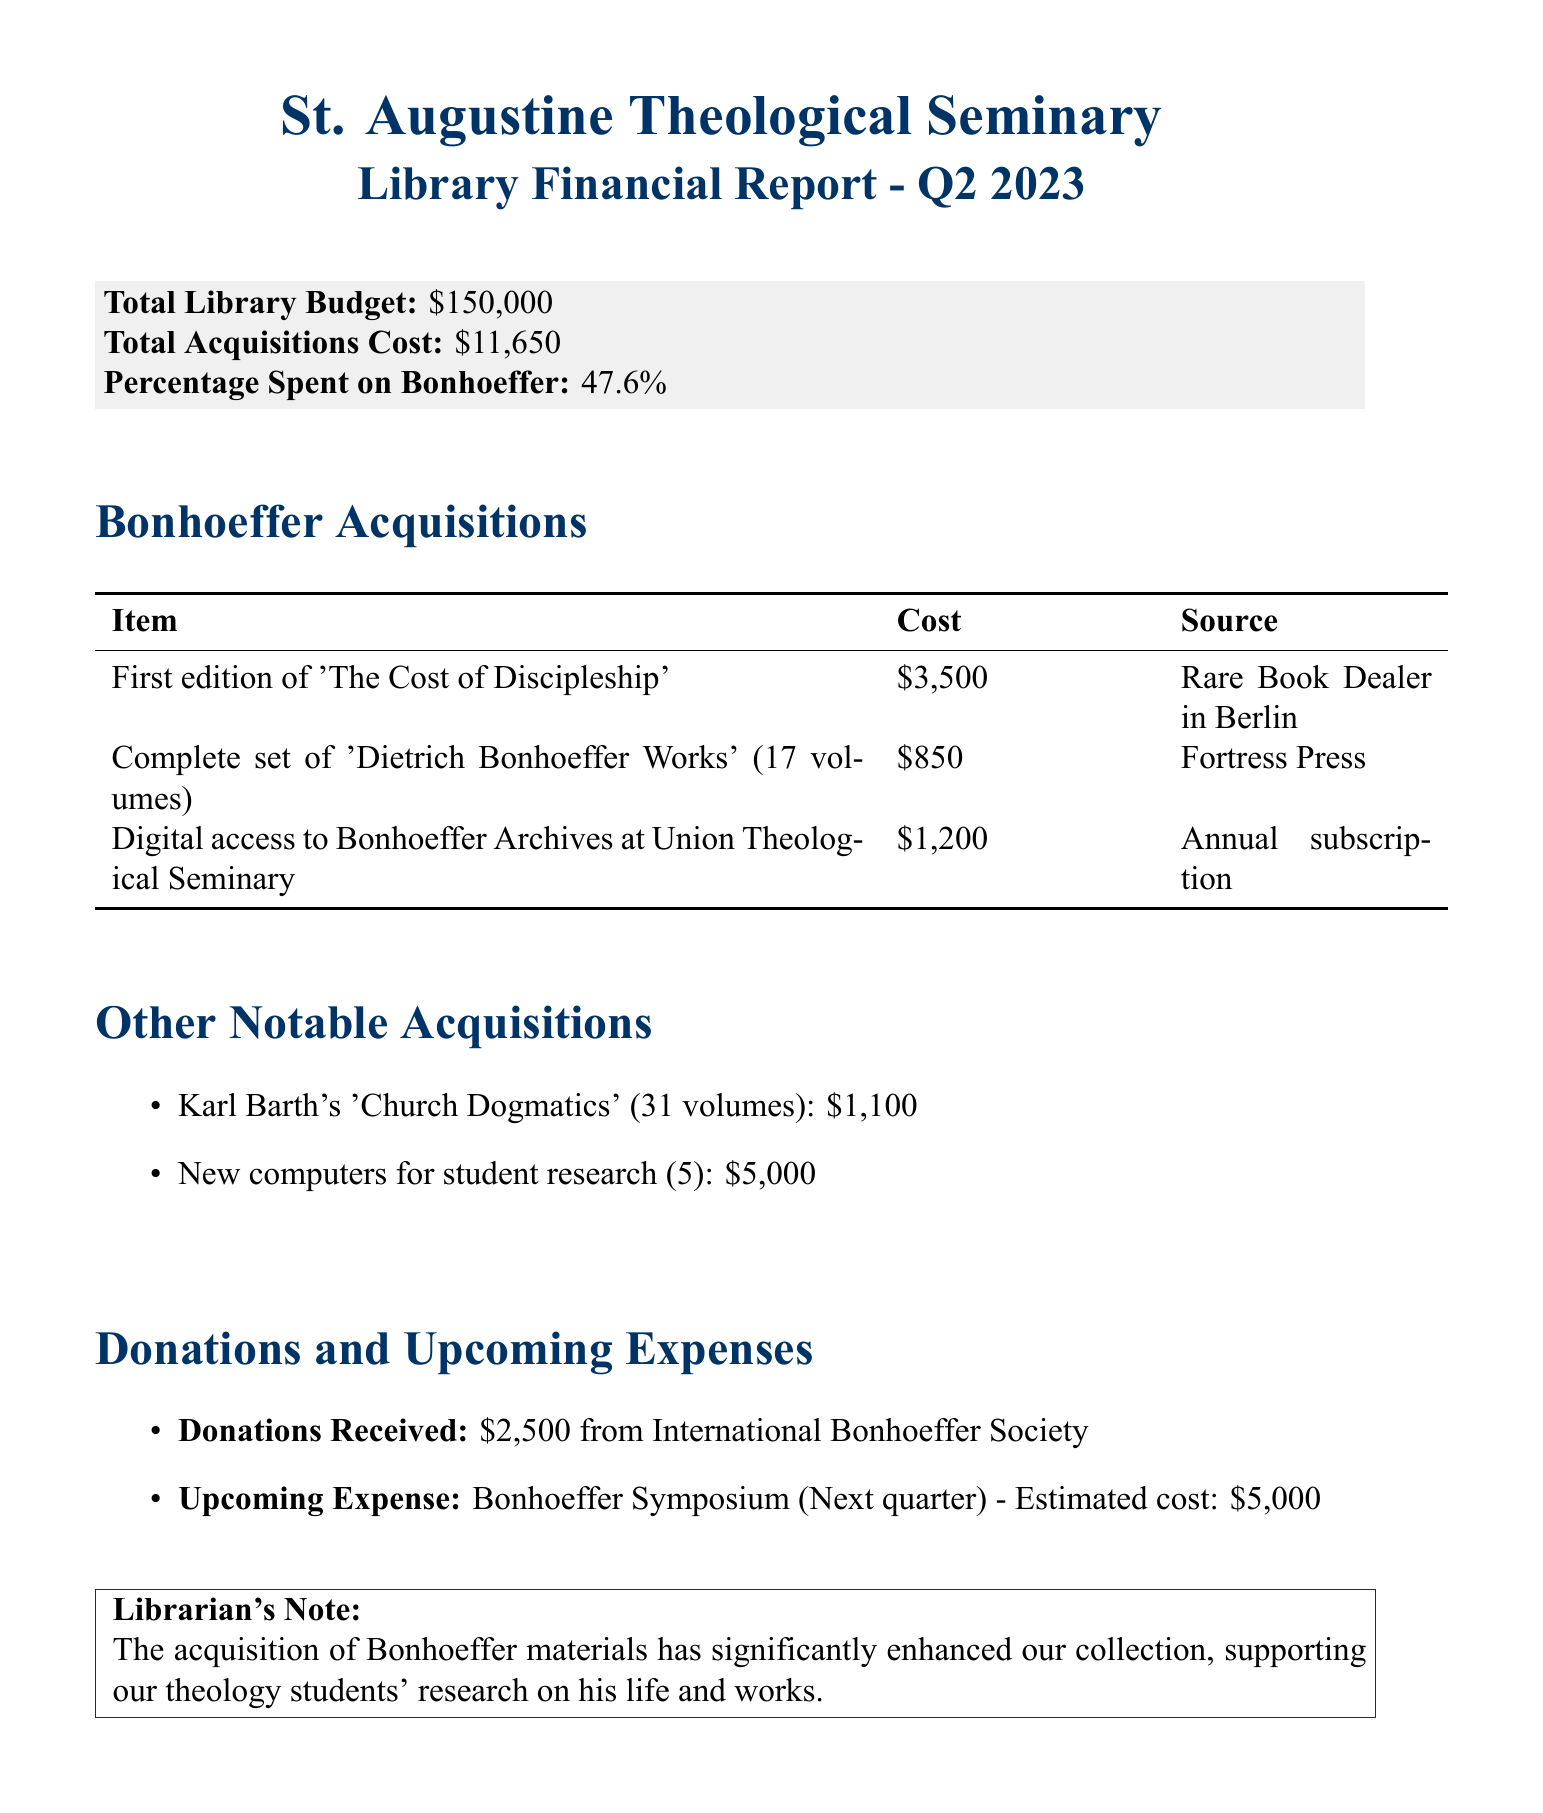What is the total library budget? The total library budget is stated in the report as $150,000.
Answer: $150,000 How much was spent on Bonhoeffer acquisitions? The total cost of Bonhoeffer acquisitions is listed as $11,650.
Answer: $11,650 What percentage of the budget was spent on Bonhoeffer materials? The report indicates that 47.6% of the budget was spent on Bonhoeffer materials.
Answer: 47.6% What is one of the notable Bonhoeffer acquisitions? The document lists several Bonhoeffer acquisitions, including the first edition of 'The Cost of Discipleship'.
Answer: First edition of 'The Cost of Discipleship' From where was the complete set of 'Dietrich Bonhoeffer Works' acquired? This information is provided, indicating Fortress Press as the source for this set.
Answer: Fortress Press What is the estimated cost for the Bonhoeffer Symposium? The estimated cost for the Bonhoeffer Symposium is explicitly stated in the report as $5,000.
Answer: $5,000 Who donated to the library, and how much was received? The report mentions donations received from the International Bonhoeffer Society amounting to $2,500.
Answer: $2,500 What is the total number of volumes in the 'Dietrich Bonhoeffer Works'? The report specifies that there are 17 volumes in the complete set of 'Dietrich Bonhoeffer Works'.
Answer: 17 volumes What is the nature of the digital access acquired for Bonhoeffer materials? The document indicates it is an annual subscription to the Bonhoeffer Archives at Union Theological Seminary.
Answer: Annual subscription 